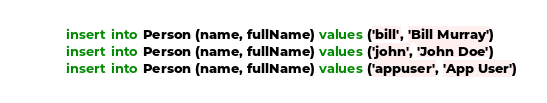Convert code to text. <code><loc_0><loc_0><loc_500><loc_500><_SQL_>insert into Person (name, fullName) values ('bill', 'Bill Murray') 
insert into Person (name, fullName) values ('john', 'John Doe') 
insert into Person (name, fullName) values ('appuser', 'App User') 
</code> 